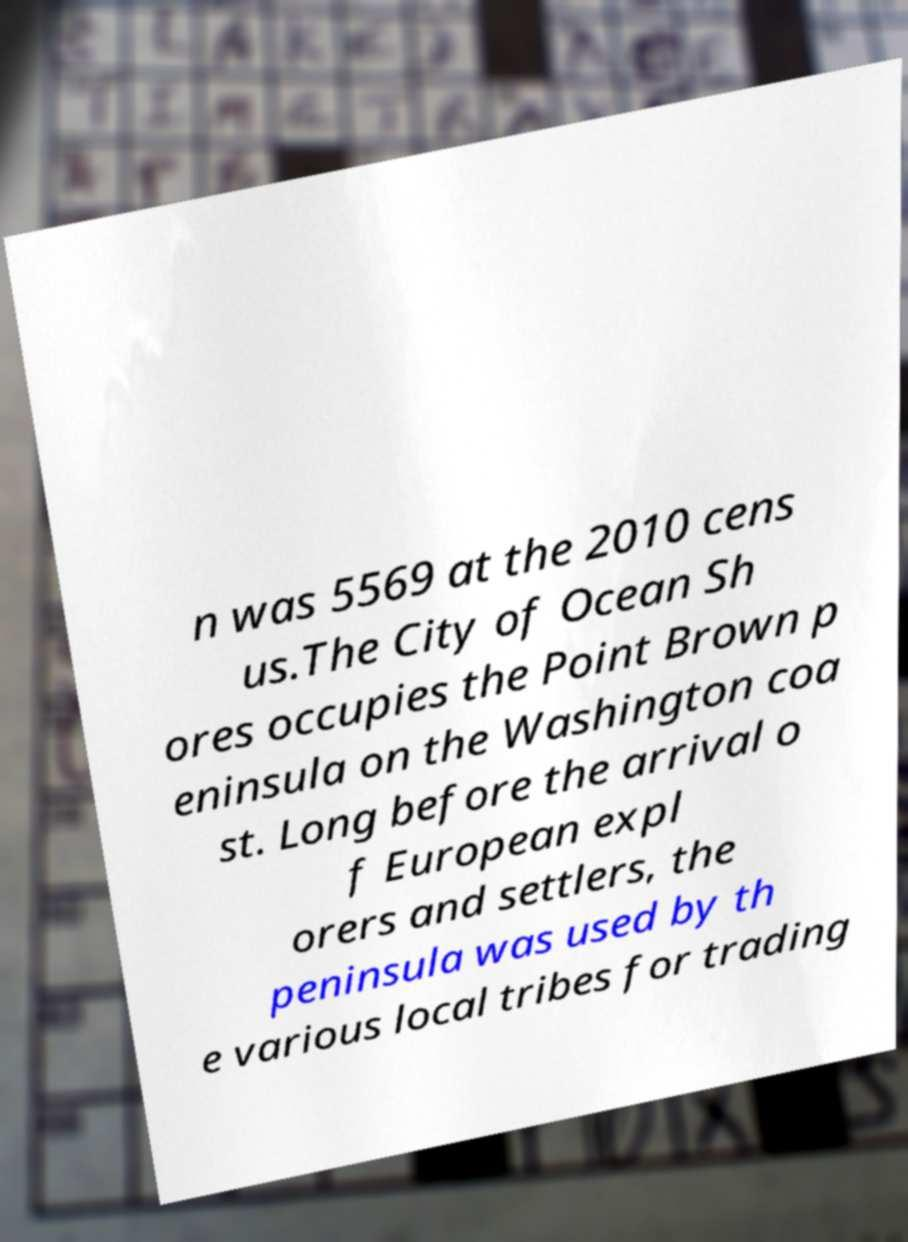For documentation purposes, I need the text within this image transcribed. Could you provide that? n was 5569 at the 2010 cens us.The City of Ocean Sh ores occupies the Point Brown p eninsula on the Washington coa st. Long before the arrival o f European expl orers and settlers, the peninsula was used by th e various local tribes for trading 